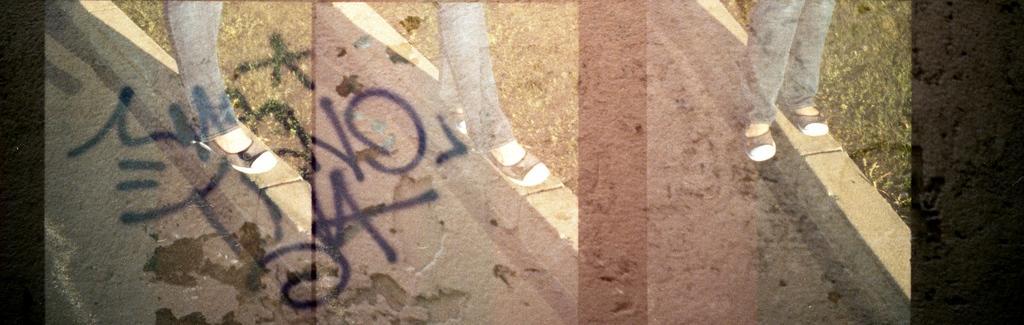How would you summarize this image in a sentence or two? In this image, on the right side, we can see the legs of a person which are covered with shoe. On the right side, we can also see a grass. In the middle of the image, we can see the legs of a person covered with chapel and standing on the wall. On the right side, we can also see a grass. On the left side, we can see some text written on the image and the legs of a person walking on the wall. On the right side, we can also see a grass. On the left side, we can see a road on all the side. On the right side and left side, we can also see black color. 